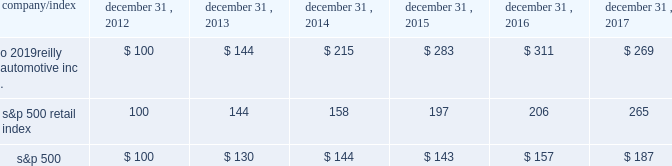Stock performance graph : the graph below shows the cumulative total shareholder return assuming the investment of $ 100 , on december 31 , 2012 , and the reinvestment of dividends thereafter , if any , in the company 2019s common stock versus the standard and poor 2019s s&p 500 retail index ( 201cs&p 500 retail index 201d ) and the standard and poor 2019s s&p 500 index ( 201cs&p 500 201d ) . .

What is the roi of an investment in s&p500 from 2016 to 2017? 
Computations: ((187 - 157) / 157)
Answer: 0.19108. 